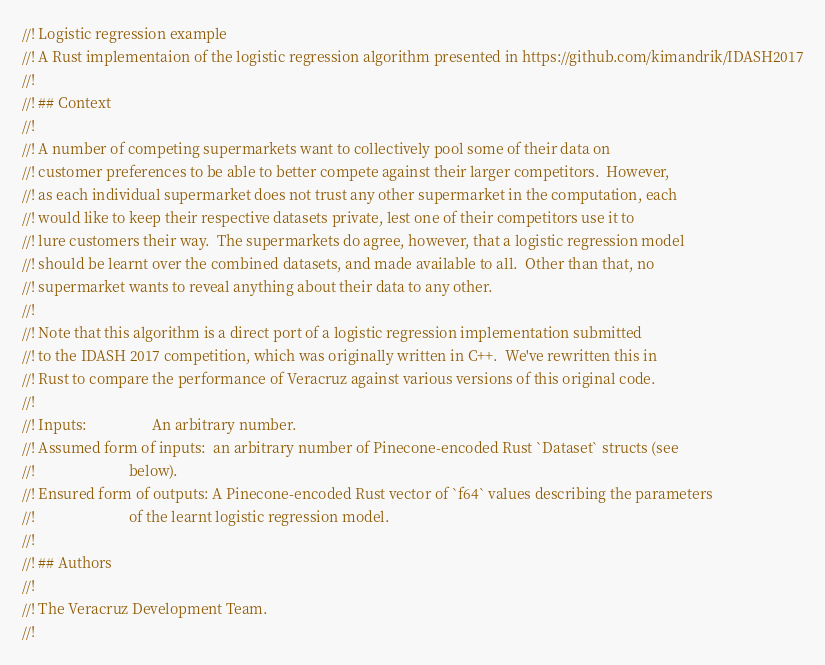Convert code to text. <code><loc_0><loc_0><loc_500><loc_500><_Rust_>//! Logistic regression example
//! A Rust implementaion of the logistic regression algorithm presented in https://github.com/kimandrik/IDASH2017
//!
//! ## Context
//!
//! A number of competing supermarkets want to collectively pool some of their data on
//! customer preferences to be able to better compete against their larger competitors.  However,
//! as each individual supermarket does not trust any other supermarket in the computation, each
//! would like to keep their respective datasets private, lest one of their competitors use it to
//! lure customers their way.  The supermarkets do agree, however, that a logistic regression model
//! should be learnt over the combined datasets, and made available to all.  Other than that, no
//! supermarket wants to reveal anything about their data to any other.
//!
//! Note that this algorithm is a direct port of a logistic regression implementation submitted
//! to the IDASH 2017 competition, which was originally written in C++.  We've rewritten this in
//! Rust to compare the performance of Veracruz against various versions of this original code.
//!
//! Inputs:                  An arbitrary number.
//! Assumed form of inputs:  an arbitrary number of Pinecone-encoded Rust `Dataset` structs (see
//!                          below).
//! Ensured form of outputs: A Pinecone-encoded Rust vector of `f64` values describing the parameters
//!                          of the learnt logistic regression model.
//!
//! ## Authors
//!
//! The Veracruz Development Team.
//!</code> 